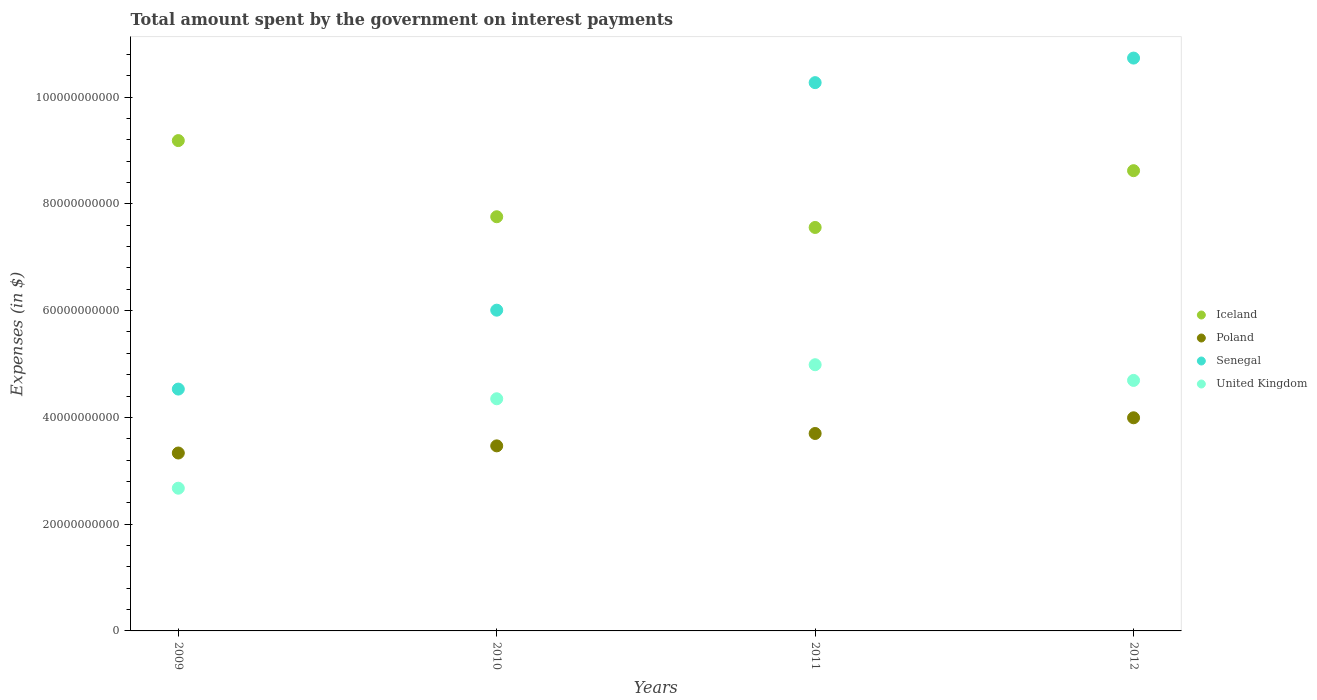How many different coloured dotlines are there?
Give a very brief answer. 4. Is the number of dotlines equal to the number of legend labels?
Ensure brevity in your answer.  Yes. What is the amount spent on interest payments by the government in United Kingdom in 2009?
Offer a terse response. 2.67e+1. Across all years, what is the maximum amount spent on interest payments by the government in Poland?
Offer a very short reply. 3.99e+1. Across all years, what is the minimum amount spent on interest payments by the government in Iceland?
Offer a terse response. 7.56e+1. In which year was the amount spent on interest payments by the government in Poland minimum?
Ensure brevity in your answer.  2009. What is the total amount spent on interest payments by the government in Poland in the graph?
Offer a terse response. 1.45e+11. What is the difference between the amount spent on interest payments by the government in Senegal in 2009 and that in 2010?
Your response must be concise. -1.48e+1. What is the difference between the amount spent on interest payments by the government in Iceland in 2011 and the amount spent on interest payments by the government in United Kingdom in 2010?
Your response must be concise. 3.21e+1. What is the average amount spent on interest payments by the government in United Kingdom per year?
Your response must be concise. 4.18e+1. In the year 2009, what is the difference between the amount spent on interest payments by the government in United Kingdom and amount spent on interest payments by the government in Iceland?
Offer a terse response. -6.51e+1. What is the ratio of the amount spent on interest payments by the government in Senegal in 2009 to that in 2011?
Offer a very short reply. 0.44. Is the difference between the amount spent on interest payments by the government in United Kingdom in 2010 and 2011 greater than the difference between the amount spent on interest payments by the government in Iceland in 2010 and 2011?
Ensure brevity in your answer.  No. What is the difference between the highest and the second highest amount spent on interest payments by the government in Senegal?
Your answer should be very brief. 4.60e+09. What is the difference between the highest and the lowest amount spent on interest payments by the government in United Kingdom?
Offer a very short reply. 2.31e+1. Is the sum of the amount spent on interest payments by the government in Poland in 2009 and 2011 greater than the maximum amount spent on interest payments by the government in United Kingdom across all years?
Make the answer very short. Yes. Is it the case that in every year, the sum of the amount spent on interest payments by the government in Senegal and amount spent on interest payments by the government in United Kingdom  is greater than the sum of amount spent on interest payments by the government in Iceland and amount spent on interest payments by the government in Poland?
Provide a short and direct response. No. Is it the case that in every year, the sum of the amount spent on interest payments by the government in Poland and amount spent on interest payments by the government in Senegal  is greater than the amount spent on interest payments by the government in Iceland?
Make the answer very short. No. Does the amount spent on interest payments by the government in Senegal monotonically increase over the years?
Your answer should be very brief. Yes. Is the amount spent on interest payments by the government in United Kingdom strictly less than the amount spent on interest payments by the government in Iceland over the years?
Give a very brief answer. Yes. How many dotlines are there?
Offer a very short reply. 4. What is the difference between two consecutive major ticks on the Y-axis?
Keep it short and to the point. 2.00e+1. Does the graph contain grids?
Offer a very short reply. No. Where does the legend appear in the graph?
Keep it short and to the point. Center right. How many legend labels are there?
Your answer should be compact. 4. What is the title of the graph?
Make the answer very short. Total amount spent by the government on interest payments. Does "East Asia (all income levels)" appear as one of the legend labels in the graph?
Your answer should be compact. No. What is the label or title of the X-axis?
Give a very brief answer. Years. What is the label or title of the Y-axis?
Ensure brevity in your answer.  Expenses (in $). What is the Expenses (in $) of Iceland in 2009?
Make the answer very short. 9.18e+1. What is the Expenses (in $) in Poland in 2009?
Offer a terse response. 3.33e+1. What is the Expenses (in $) in Senegal in 2009?
Your answer should be very brief. 4.53e+1. What is the Expenses (in $) of United Kingdom in 2009?
Provide a short and direct response. 2.67e+1. What is the Expenses (in $) of Iceland in 2010?
Offer a very short reply. 7.76e+1. What is the Expenses (in $) in Poland in 2010?
Offer a terse response. 3.47e+1. What is the Expenses (in $) in Senegal in 2010?
Make the answer very short. 6.01e+1. What is the Expenses (in $) of United Kingdom in 2010?
Keep it short and to the point. 4.35e+1. What is the Expenses (in $) in Iceland in 2011?
Offer a terse response. 7.56e+1. What is the Expenses (in $) of Poland in 2011?
Your answer should be very brief. 3.70e+1. What is the Expenses (in $) of Senegal in 2011?
Your answer should be compact. 1.03e+11. What is the Expenses (in $) in United Kingdom in 2011?
Your answer should be very brief. 4.99e+1. What is the Expenses (in $) in Iceland in 2012?
Your answer should be compact. 8.62e+1. What is the Expenses (in $) in Poland in 2012?
Give a very brief answer. 3.99e+1. What is the Expenses (in $) of Senegal in 2012?
Offer a very short reply. 1.07e+11. What is the Expenses (in $) in United Kingdom in 2012?
Keep it short and to the point. 4.69e+1. Across all years, what is the maximum Expenses (in $) in Iceland?
Give a very brief answer. 9.18e+1. Across all years, what is the maximum Expenses (in $) in Poland?
Your response must be concise. 3.99e+1. Across all years, what is the maximum Expenses (in $) in Senegal?
Ensure brevity in your answer.  1.07e+11. Across all years, what is the maximum Expenses (in $) in United Kingdom?
Your response must be concise. 4.99e+1. Across all years, what is the minimum Expenses (in $) of Iceland?
Make the answer very short. 7.56e+1. Across all years, what is the minimum Expenses (in $) in Poland?
Give a very brief answer. 3.33e+1. Across all years, what is the minimum Expenses (in $) of Senegal?
Your answer should be very brief. 4.53e+1. Across all years, what is the minimum Expenses (in $) in United Kingdom?
Make the answer very short. 2.67e+1. What is the total Expenses (in $) in Iceland in the graph?
Provide a succinct answer. 3.31e+11. What is the total Expenses (in $) in Poland in the graph?
Your answer should be compact. 1.45e+11. What is the total Expenses (in $) of Senegal in the graph?
Make the answer very short. 3.15e+11. What is the total Expenses (in $) in United Kingdom in the graph?
Provide a short and direct response. 1.67e+11. What is the difference between the Expenses (in $) of Iceland in 2009 and that in 2010?
Offer a terse response. 1.43e+1. What is the difference between the Expenses (in $) in Poland in 2009 and that in 2010?
Your answer should be compact. -1.34e+09. What is the difference between the Expenses (in $) of Senegal in 2009 and that in 2010?
Provide a succinct answer. -1.48e+1. What is the difference between the Expenses (in $) in United Kingdom in 2009 and that in 2010?
Give a very brief answer. -1.68e+1. What is the difference between the Expenses (in $) in Iceland in 2009 and that in 2011?
Your answer should be compact. 1.63e+1. What is the difference between the Expenses (in $) in Poland in 2009 and that in 2011?
Provide a succinct answer. -3.66e+09. What is the difference between the Expenses (in $) in Senegal in 2009 and that in 2011?
Keep it short and to the point. -5.74e+1. What is the difference between the Expenses (in $) in United Kingdom in 2009 and that in 2011?
Your answer should be compact. -2.31e+1. What is the difference between the Expenses (in $) of Iceland in 2009 and that in 2012?
Provide a short and direct response. 5.63e+09. What is the difference between the Expenses (in $) in Poland in 2009 and that in 2012?
Ensure brevity in your answer.  -6.60e+09. What is the difference between the Expenses (in $) in Senegal in 2009 and that in 2012?
Provide a succinct answer. -6.20e+1. What is the difference between the Expenses (in $) in United Kingdom in 2009 and that in 2012?
Your response must be concise. -2.02e+1. What is the difference between the Expenses (in $) of Iceland in 2010 and that in 2011?
Provide a short and direct response. 2.01e+09. What is the difference between the Expenses (in $) of Poland in 2010 and that in 2011?
Ensure brevity in your answer.  -2.32e+09. What is the difference between the Expenses (in $) in Senegal in 2010 and that in 2011?
Provide a succinct answer. -4.26e+1. What is the difference between the Expenses (in $) of United Kingdom in 2010 and that in 2011?
Make the answer very short. -6.38e+09. What is the difference between the Expenses (in $) of Iceland in 2010 and that in 2012?
Your response must be concise. -8.63e+09. What is the difference between the Expenses (in $) in Poland in 2010 and that in 2012?
Keep it short and to the point. -5.26e+09. What is the difference between the Expenses (in $) in Senegal in 2010 and that in 2012?
Provide a succinct answer. -4.72e+1. What is the difference between the Expenses (in $) in United Kingdom in 2010 and that in 2012?
Ensure brevity in your answer.  -3.44e+09. What is the difference between the Expenses (in $) of Iceland in 2011 and that in 2012?
Provide a short and direct response. -1.06e+1. What is the difference between the Expenses (in $) of Poland in 2011 and that in 2012?
Your response must be concise. -2.94e+09. What is the difference between the Expenses (in $) in Senegal in 2011 and that in 2012?
Your response must be concise. -4.60e+09. What is the difference between the Expenses (in $) in United Kingdom in 2011 and that in 2012?
Keep it short and to the point. 2.94e+09. What is the difference between the Expenses (in $) of Iceland in 2009 and the Expenses (in $) of Poland in 2010?
Your response must be concise. 5.72e+1. What is the difference between the Expenses (in $) in Iceland in 2009 and the Expenses (in $) in Senegal in 2010?
Your answer should be compact. 3.18e+1. What is the difference between the Expenses (in $) of Iceland in 2009 and the Expenses (in $) of United Kingdom in 2010?
Your answer should be very brief. 4.84e+1. What is the difference between the Expenses (in $) of Poland in 2009 and the Expenses (in $) of Senegal in 2010?
Provide a succinct answer. -2.68e+1. What is the difference between the Expenses (in $) in Poland in 2009 and the Expenses (in $) in United Kingdom in 2010?
Make the answer very short. -1.02e+1. What is the difference between the Expenses (in $) of Senegal in 2009 and the Expenses (in $) of United Kingdom in 2010?
Your answer should be very brief. 1.82e+09. What is the difference between the Expenses (in $) in Iceland in 2009 and the Expenses (in $) in Poland in 2011?
Keep it short and to the point. 5.49e+1. What is the difference between the Expenses (in $) of Iceland in 2009 and the Expenses (in $) of Senegal in 2011?
Your answer should be compact. -1.09e+1. What is the difference between the Expenses (in $) in Iceland in 2009 and the Expenses (in $) in United Kingdom in 2011?
Ensure brevity in your answer.  4.20e+1. What is the difference between the Expenses (in $) of Poland in 2009 and the Expenses (in $) of Senegal in 2011?
Your answer should be very brief. -6.94e+1. What is the difference between the Expenses (in $) of Poland in 2009 and the Expenses (in $) of United Kingdom in 2011?
Your answer should be very brief. -1.65e+1. What is the difference between the Expenses (in $) in Senegal in 2009 and the Expenses (in $) in United Kingdom in 2011?
Keep it short and to the point. -4.56e+09. What is the difference between the Expenses (in $) of Iceland in 2009 and the Expenses (in $) of Poland in 2012?
Your answer should be compact. 5.19e+1. What is the difference between the Expenses (in $) of Iceland in 2009 and the Expenses (in $) of Senegal in 2012?
Provide a short and direct response. -1.55e+1. What is the difference between the Expenses (in $) of Iceland in 2009 and the Expenses (in $) of United Kingdom in 2012?
Provide a succinct answer. 4.49e+1. What is the difference between the Expenses (in $) in Poland in 2009 and the Expenses (in $) in Senegal in 2012?
Offer a very short reply. -7.40e+1. What is the difference between the Expenses (in $) in Poland in 2009 and the Expenses (in $) in United Kingdom in 2012?
Your answer should be very brief. -1.36e+1. What is the difference between the Expenses (in $) of Senegal in 2009 and the Expenses (in $) of United Kingdom in 2012?
Make the answer very short. -1.62e+09. What is the difference between the Expenses (in $) in Iceland in 2010 and the Expenses (in $) in Poland in 2011?
Offer a terse response. 4.06e+1. What is the difference between the Expenses (in $) of Iceland in 2010 and the Expenses (in $) of Senegal in 2011?
Your response must be concise. -2.51e+1. What is the difference between the Expenses (in $) of Iceland in 2010 and the Expenses (in $) of United Kingdom in 2011?
Your answer should be very brief. 2.77e+1. What is the difference between the Expenses (in $) of Poland in 2010 and the Expenses (in $) of Senegal in 2011?
Give a very brief answer. -6.80e+1. What is the difference between the Expenses (in $) in Poland in 2010 and the Expenses (in $) in United Kingdom in 2011?
Give a very brief answer. -1.52e+1. What is the difference between the Expenses (in $) of Senegal in 2010 and the Expenses (in $) of United Kingdom in 2011?
Provide a short and direct response. 1.02e+1. What is the difference between the Expenses (in $) in Iceland in 2010 and the Expenses (in $) in Poland in 2012?
Keep it short and to the point. 3.77e+1. What is the difference between the Expenses (in $) in Iceland in 2010 and the Expenses (in $) in Senegal in 2012?
Your response must be concise. -2.97e+1. What is the difference between the Expenses (in $) in Iceland in 2010 and the Expenses (in $) in United Kingdom in 2012?
Make the answer very short. 3.07e+1. What is the difference between the Expenses (in $) of Poland in 2010 and the Expenses (in $) of Senegal in 2012?
Make the answer very short. -7.26e+1. What is the difference between the Expenses (in $) of Poland in 2010 and the Expenses (in $) of United Kingdom in 2012?
Your response must be concise. -1.23e+1. What is the difference between the Expenses (in $) of Senegal in 2010 and the Expenses (in $) of United Kingdom in 2012?
Give a very brief answer. 1.32e+1. What is the difference between the Expenses (in $) of Iceland in 2011 and the Expenses (in $) of Poland in 2012?
Your answer should be compact. 3.57e+1. What is the difference between the Expenses (in $) of Iceland in 2011 and the Expenses (in $) of Senegal in 2012?
Ensure brevity in your answer.  -3.17e+1. What is the difference between the Expenses (in $) in Iceland in 2011 and the Expenses (in $) in United Kingdom in 2012?
Provide a short and direct response. 2.87e+1. What is the difference between the Expenses (in $) of Poland in 2011 and the Expenses (in $) of Senegal in 2012?
Make the answer very short. -7.03e+1. What is the difference between the Expenses (in $) in Poland in 2011 and the Expenses (in $) in United Kingdom in 2012?
Ensure brevity in your answer.  -9.94e+09. What is the difference between the Expenses (in $) in Senegal in 2011 and the Expenses (in $) in United Kingdom in 2012?
Offer a terse response. 5.58e+1. What is the average Expenses (in $) in Iceland per year?
Your answer should be compact. 8.28e+1. What is the average Expenses (in $) in Poland per year?
Ensure brevity in your answer.  3.62e+1. What is the average Expenses (in $) in Senegal per year?
Provide a short and direct response. 7.88e+1. What is the average Expenses (in $) of United Kingdom per year?
Offer a very short reply. 4.18e+1. In the year 2009, what is the difference between the Expenses (in $) of Iceland and Expenses (in $) of Poland?
Offer a terse response. 5.85e+1. In the year 2009, what is the difference between the Expenses (in $) in Iceland and Expenses (in $) in Senegal?
Make the answer very short. 4.65e+1. In the year 2009, what is the difference between the Expenses (in $) of Iceland and Expenses (in $) of United Kingdom?
Offer a very short reply. 6.51e+1. In the year 2009, what is the difference between the Expenses (in $) in Poland and Expenses (in $) in Senegal?
Your answer should be very brief. -1.20e+1. In the year 2009, what is the difference between the Expenses (in $) of Poland and Expenses (in $) of United Kingdom?
Your answer should be compact. 6.59e+09. In the year 2009, what is the difference between the Expenses (in $) in Senegal and Expenses (in $) in United Kingdom?
Offer a very short reply. 1.86e+1. In the year 2010, what is the difference between the Expenses (in $) in Iceland and Expenses (in $) in Poland?
Provide a succinct answer. 4.29e+1. In the year 2010, what is the difference between the Expenses (in $) in Iceland and Expenses (in $) in Senegal?
Give a very brief answer. 1.75e+1. In the year 2010, what is the difference between the Expenses (in $) in Iceland and Expenses (in $) in United Kingdom?
Offer a terse response. 3.41e+1. In the year 2010, what is the difference between the Expenses (in $) in Poland and Expenses (in $) in Senegal?
Offer a very short reply. -2.54e+1. In the year 2010, what is the difference between the Expenses (in $) in Poland and Expenses (in $) in United Kingdom?
Provide a succinct answer. -8.82e+09. In the year 2010, what is the difference between the Expenses (in $) of Senegal and Expenses (in $) of United Kingdom?
Offer a terse response. 1.66e+1. In the year 2011, what is the difference between the Expenses (in $) in Iceland and Expenses (in $) in Poland?
Keep it short and to the point. 3.86e+1. In the year 2011, what is the difference between the Expenses (in $) of Iceland and Expenses (in $) of Senegal?
Offer a terse response. -2.71e+1. In the year 2011, what is the difference between the Expenses (in $) in Iceland and Expenses (in $) in United Kingdom?
Make the answer very short. 2.57e+1. In the year 2011, what is the difference between the Expenses (in $) in Poland and Expenses (in $) in Senegal?
Provide a short and direct response. -6.57e+1. In the year 2011, what is the difference between the Expenses (in $) in Poland and Expenses (in $) in United Kingdom?
Your answer should be compact. -1.29e+1. In the year 2011, what is the difference between the Expenses (in $) of Senegal and Expenses (in $) of United Kingdom?
Your answer should be very brief. 5.28e+1. In the year 2012, what is the difference between the Expenses (in $) of Iceland and Expenses (in $) of Poland?
Provide a succinct answer. 4.63e+1. In the year 2012, what is the difference between the Expenses (in $) in Iceland and Expenses (in $) in Senegal?
Keep it short and to the point. -2.11e+1. In the year 2012, what is the difference between the Expenses (in $) of Iceland and Expenses (in $) of United Kingdom?
Give a very brief answer. 3.93e+1. In the year 2012, what is the difference between the Expenses (in $) in Poland and Expenses (in $) in Senegal?
Keep it short and to the point. -6.74e+1. In the year 2012, what is the difference between the Expenses (in $) in Poland and Expenses (in $) in United Kingdom?
Make the answer very short. -7.00e+09. In the year 2012, what is the difference between the Expenses (in $) of Senegal and Expenses (in $) of United Kingdom?
Make the answer very short. 6.04e+1. What is the ratio of the Expenses (in $) in Iceland in 2009 to that in 2010?
Your answer should be compact. 1.18. What is the ratio of the Expenses (in $) of Poland in 2009 to that in 2010?
Your response must be concise. 0.96. What is the ratio of the Expenses (in $) of Senegal in 2009 to that in 2010?
Provide a succinct answer. 0.75. What is the ratio of the Expenses (in $) in United Kingdom in 2009 to that in 2010?
Your answer should be compact. 0.61. What is the ratio of the Expenses (in $) in Iceland in 2009 to that in 2011?
Make the answer very short. 1.22. What is the ratio of the Expenses (in $) in Poland in 2009 to that in 2011?
Keep it short and to the point. 0.9. What is the ratio of the Expenses (in $) of Senegal in 2009 to that in 2011?
Ensure brevity in your answer.  0.44. What is the ratio of the Expenses (in $) in United Kingdom in 2009 to that in 2011?
Keep it short and to the point. 0.54. What is the ratio of the Expenses (in $) in Iceland in 2009 to that in 2012?
Keep it short and to the point. 1.07. What is the ratio of the Expenses (in $) of Poland in 2009 to that in 2012?
Offer a terse response. 0.83. What is the ratio of the Expenses (in $) of Senegal in 2009 to that in 2012?
Provide a short and direct response. 0.42. What is the ratio of the Expenses (in $) of United Kingdom in 2009 to that in 2012?
Give a very brief answer. 0.57. What is the ratio of the Expenses (in $) of Iceland in 2010 to that in 2011?
Provide a succinct answer. 1.03. What is the ratio of the Expenses (in $) of Poland in 2010 to that in 2011?
Your answer should be compact. 0.94. What is the ratio of the Expenses (in $) of Senegal in 2010 to that in 2011?
Offer a very short reply. 0.58. What is the ratio of the Expenses (in $) of United Kingdom in 2010 to that in 2011?
Your answer should be compact. 0.87. What is the ratio of the Expenses (in $) in Iceland in 2010 to that in 2012?
Keep it short and to the point. 0.9. What is the ratio of the Expenses (in $) in Poland in 2010 to that in 2012?
Make the answer very short. 0.87. What is the ratio of the Expenses (in $) of Senegal in 2010 to that in 2012?
Offer a terse response. 0.56. What is the ratio of the Expenses (in $) in United Kingdom in 2010 to that in 2012?
Provide a short and direct response. 0.93. What is the ratio of the Expenses (in $) of Iceland in 2011 to that in 2012?
Ensure brevity in your answer.  0.88. What is the ratio of the Expenses (in $) of Poland in 2011 to that in 2012?
Your response must be concise. 0.93. What is the ratio of the Expenses (in $) of Senegal in 2011 to that in 2012?
Your answer should be compact. 0.96. What is the ratio of the Expenses (in $) in United Kingdom in 2011 to that in 2012?
Offer a terse response. 1.06. What is the difference between the highest and the second highest Expenses (in $) of Iceland?
Offer a terse response. 5.63e+09. What is the difference between the highest and the second highest Expenses (in $) of Poland?
Your answer should be very brief. 2.94e+09. What is the difference between the highest and the second highest Expenses (in $) in Senegal?
Ensure brevity in your answer.  4.60e+09. What is the difference between the highest and the second highest Expenses (in $) in United Kingdom?
Give a very brief answer. 2.94e+09. What is the difference between the highest and the lowest Expenses (in $) in Iceland?
Provide a short and direct response. 1.63e+1. What is the difference between the highest and the lowest Expenses (in $) in Poland?
Offer a terse response. 6.60e+09. What is the difference between the highest and the lowest Expenses (in $) in Senegal?
Keep it short and to the point. 6.20e+1. What is the difference between the highest and the lowest Expenses (in $) of United Kingdom?
Offer a very short reply. 2.31e+1. 